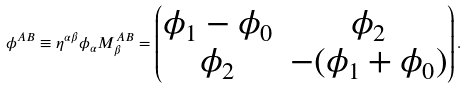<formula> <loc_0><loc_0><loc_500><loc_500>\phi ^ { A B } \equiv \eta ^ { \alpha \beta } \phi _ { \alpha } M _ { \beta } ^ { A B } = \begin{pmatrix} \phi _ { 1 } - \phi _ { 0 } & \phi _ { 2 } \\ \phi _ { 2 } & - ( \phi _ { 1 } + \phi _ { 0 } ) \end{pmatrix} .</formula> 